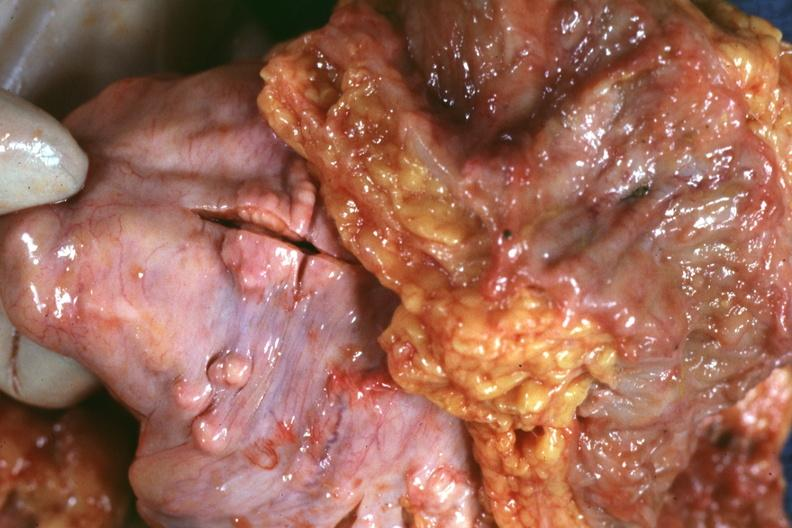s abdomen present?
Answer the question using a single word or phrase. Yes 